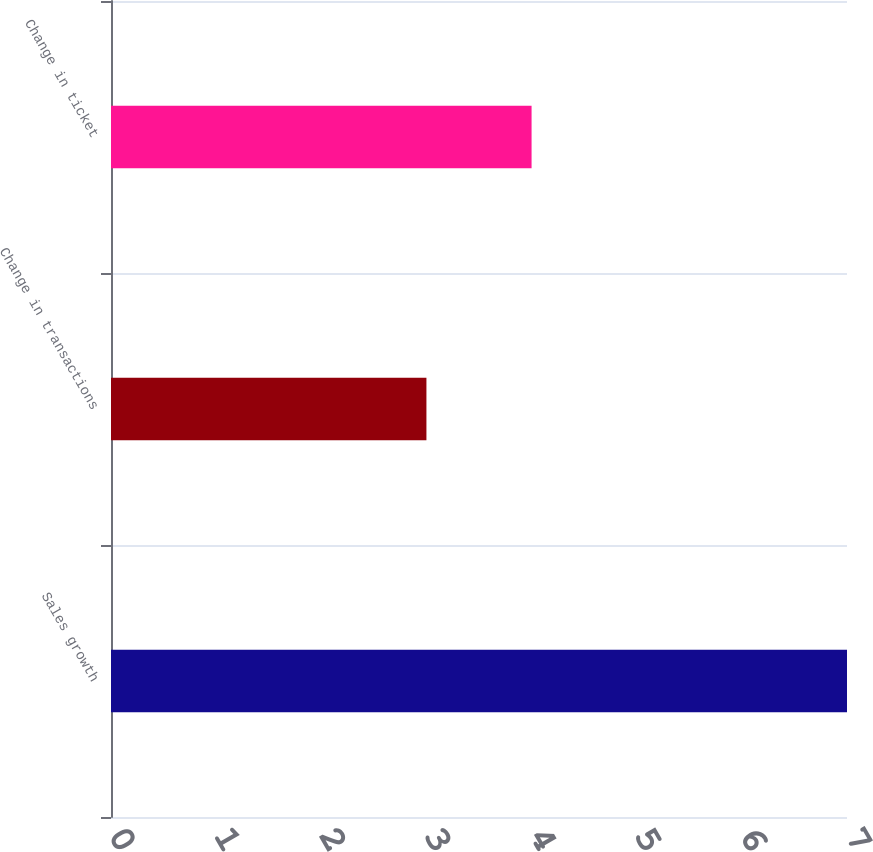<chart> <loc_0><loc_0><loc_500><loc_500><bar_chart><fcel>Sales growth<fcel>Change in transactions<fcel>Change in ticket<nl><fcel>7<fcel>3<fcel>4<nl></chart> 